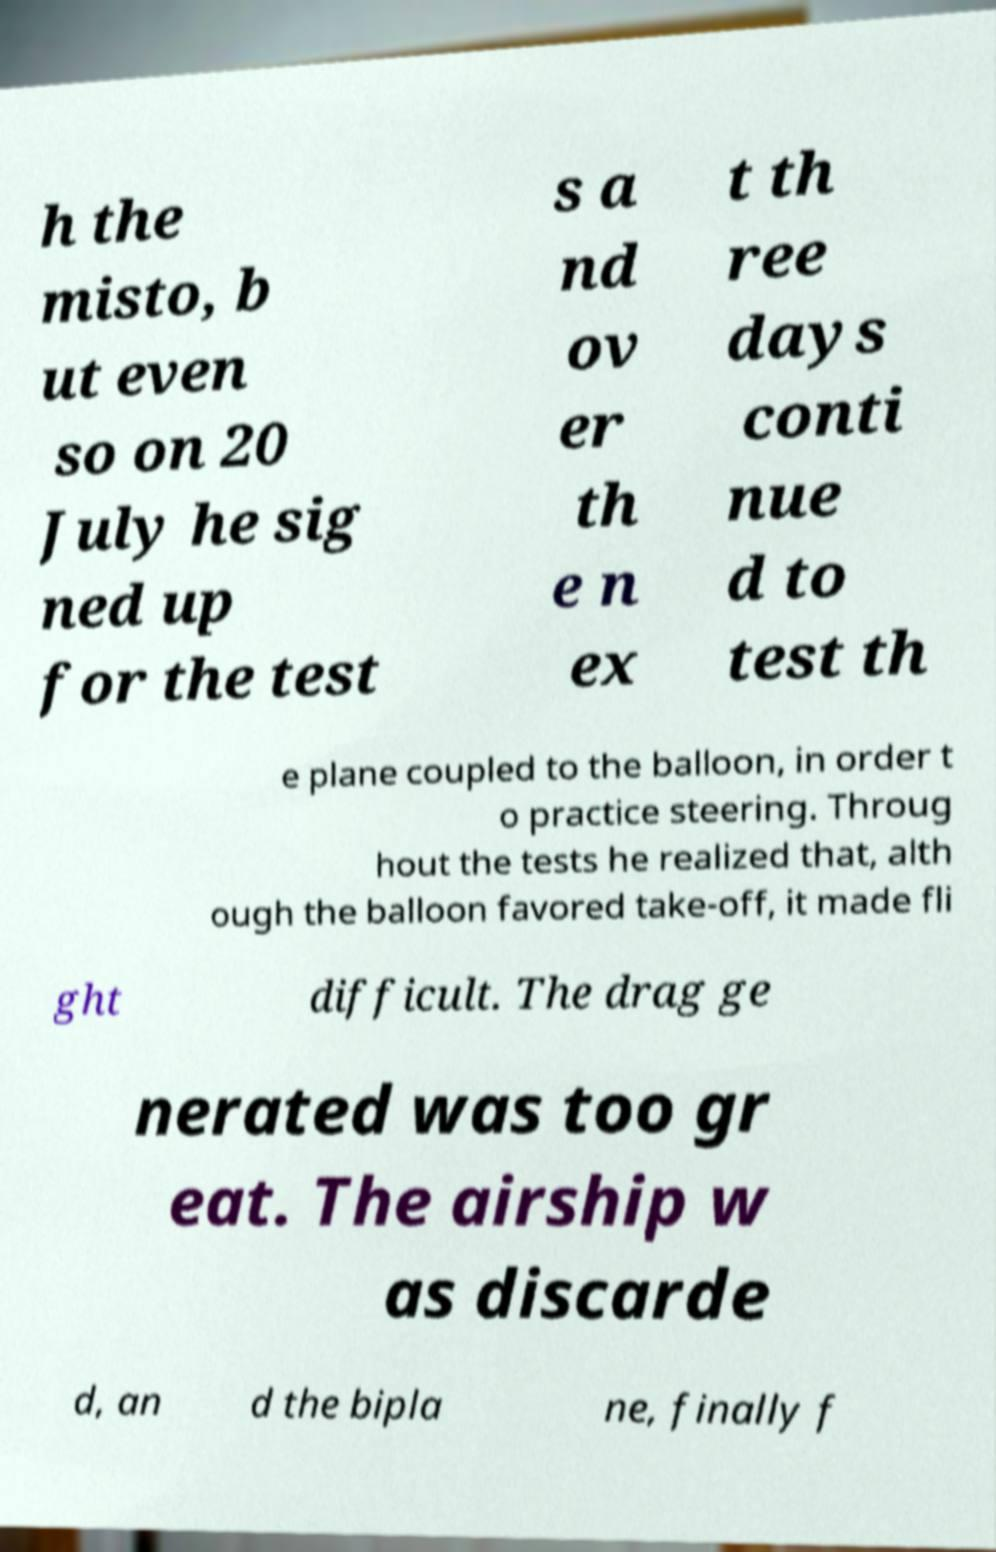Could you assist in decoding the text presented in this image and type it out clearly? h the misto, b ut even so on 20 July he sig ned up for the test s a nd ov er th e n ex t th ree days conti nue d to test th e plane coupled to the balloon, in order t o practice steering. Throug hout the tests he realized that, alth ough the balloon favored take-off, it made fli ght difficult. The drag ge nerated was too gr eat. The airship w as discarde d, an d the bipla ne, finally f 